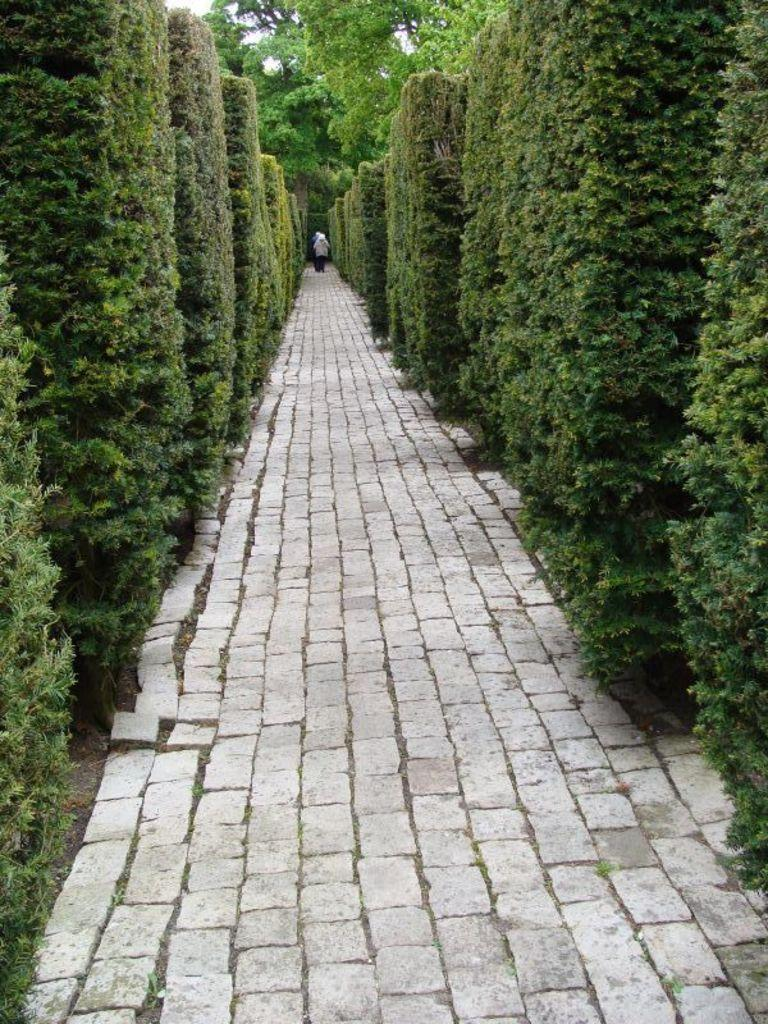What type of surface is visible in the image? There is a road with stones in the image. What is the person in the image doing? A person is walking on the path. What can be seen on both sides of the path in the image? There are trees on the right side and the left side of the image. What is visible in the background of the image? There are trees in the background of the image. What part of the natural environment is visible in the image? The sky is visible in the image. What book is the person reading while walking on the path in the image? There is no book or reading activity depicted in the image; the person is simply walking on the path. How much debt does the person owe, as seen in the image? There is no indication of debt or financial matters in the image; it focuses on the person walking on the path and the surrounding environment. 